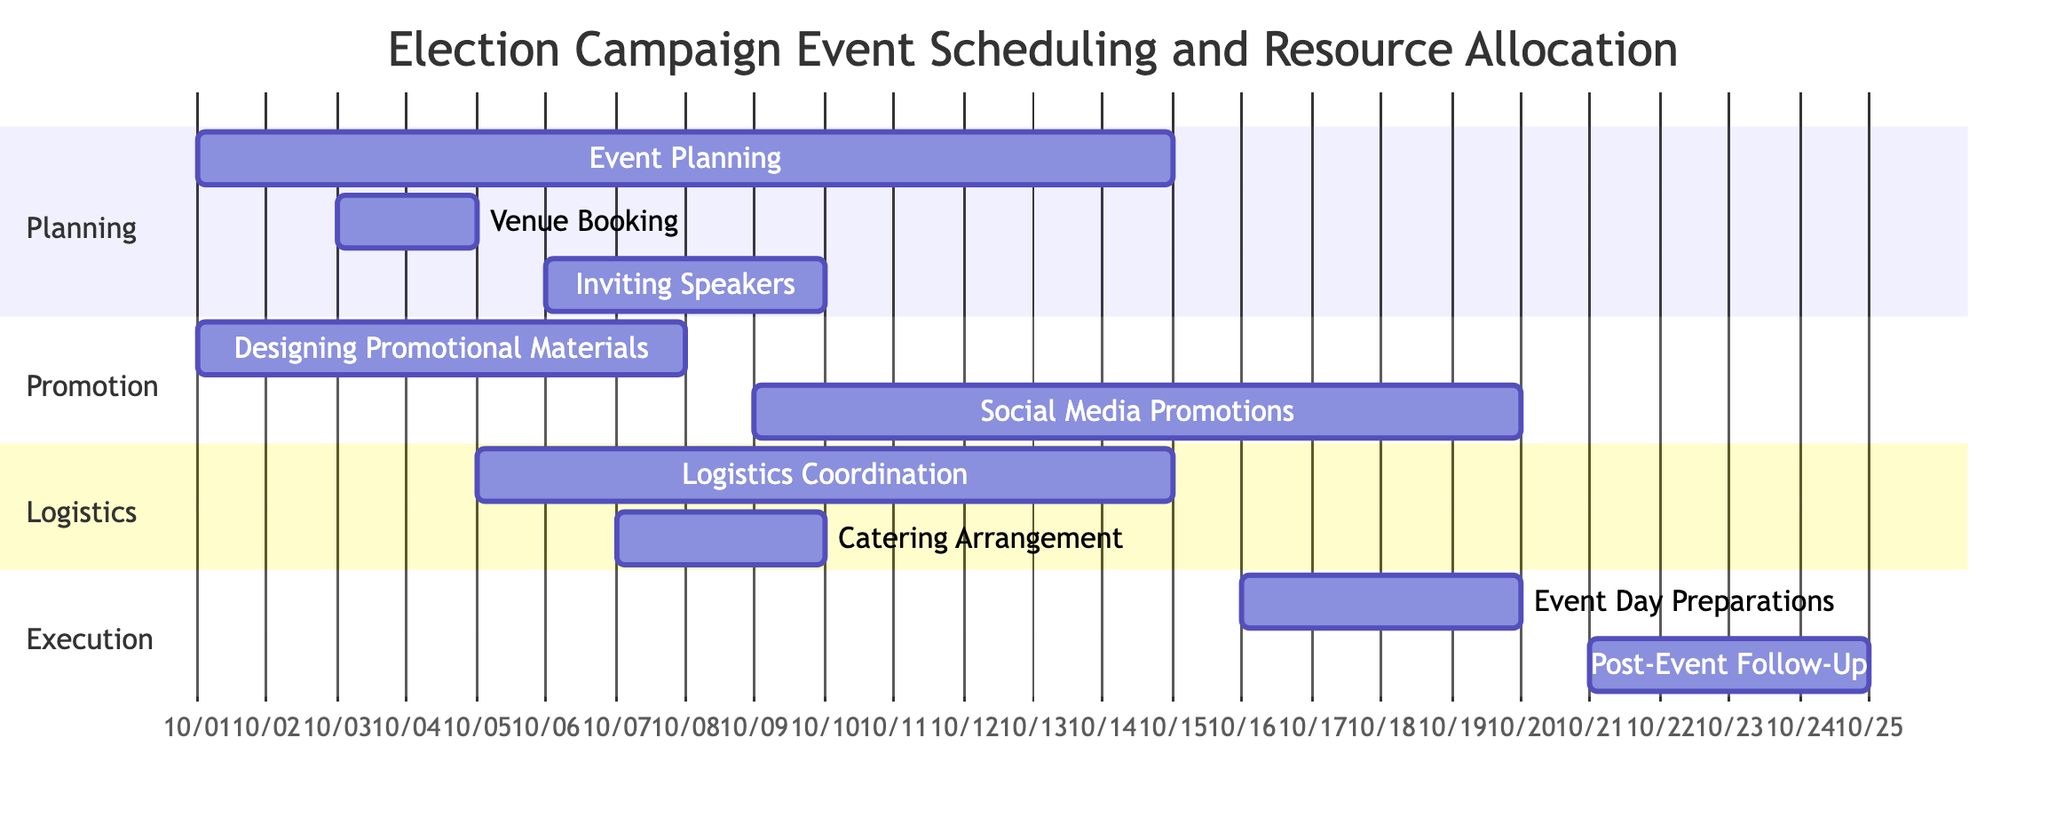What is the duration of the "Event Planning" task? The "Event Planning" task starts on October 1, 2023, and ends on October 15, 2023. The duration can be calculated by counting the days between these two dates, which totals to 15 days.
Answer: 15 days Which task begins after "Designing Promotional Materials"? "Social Media Promotions" is scheduled to start after "Designing Promotional Materials" ends on October 8, 2023. Therefore, "Social Media Promotions" begins on October 9, 2023.
Answer: Social Media Promotions How many tasks are dependent on "Venue Booking"? There are two tasks that depend on "Venue Booking": "Logistics Coordination" and "Catering Arrangement". Thus, the total is 2 tasks.
Answer: 2 tasks What is the start date of the "Post-Event Follow-Up" task? The "Post-Event Follow-Up" task is scheduled to start on October 21, 2023, which follows the completion of the "Event Day Preparations" task.
Answer: October 21, 2023 List the sections in the Gantt chart. The Gantt chart has three distinct sections: "Planning", "Promotion", "Logistics", and "Execution". In total, there are four sections present.
Answer: Planning, Promotion, Logistics, Execution Which task has the latest end date? The task with the latest end date is "Post-Event Follow-Up", which is set to conclude on October 25, 2023.
Answer: October 25, 2023 How many tasks are scheduled to occur in the "Execution" section? The "Execution" section contains two tasks: "Event Day Preparations" and "Post-Event Follow-Up". This means there are a total of 2 tasks in this section.
Answer: 2 tasks What is the relationship between "Logistics Coordination" and "Catering Arrangement"? Both "Logistics Coordination" and "Catering Arrangement" are dependent on the completion of "Venue Booking". This indicates that they are parallel tasks which start after "Venue Booking" is finished.
Answer: Both are dependent on Venue Booking 